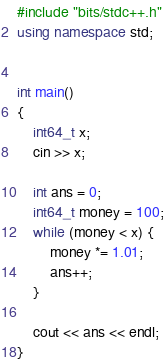<code> <loc_0><loc_0><loc_500><loc_500><_C++_>#include "bits/stdc++.h"
using namespace std;


int main()
{
	int64_t x;
	cin >> x;

	int ans = 0;
	int64_t money = 100;
	while (money < x) {
		money *= 1.01;
		ans++;
	}

	cout << ans << endl;
}</code> 